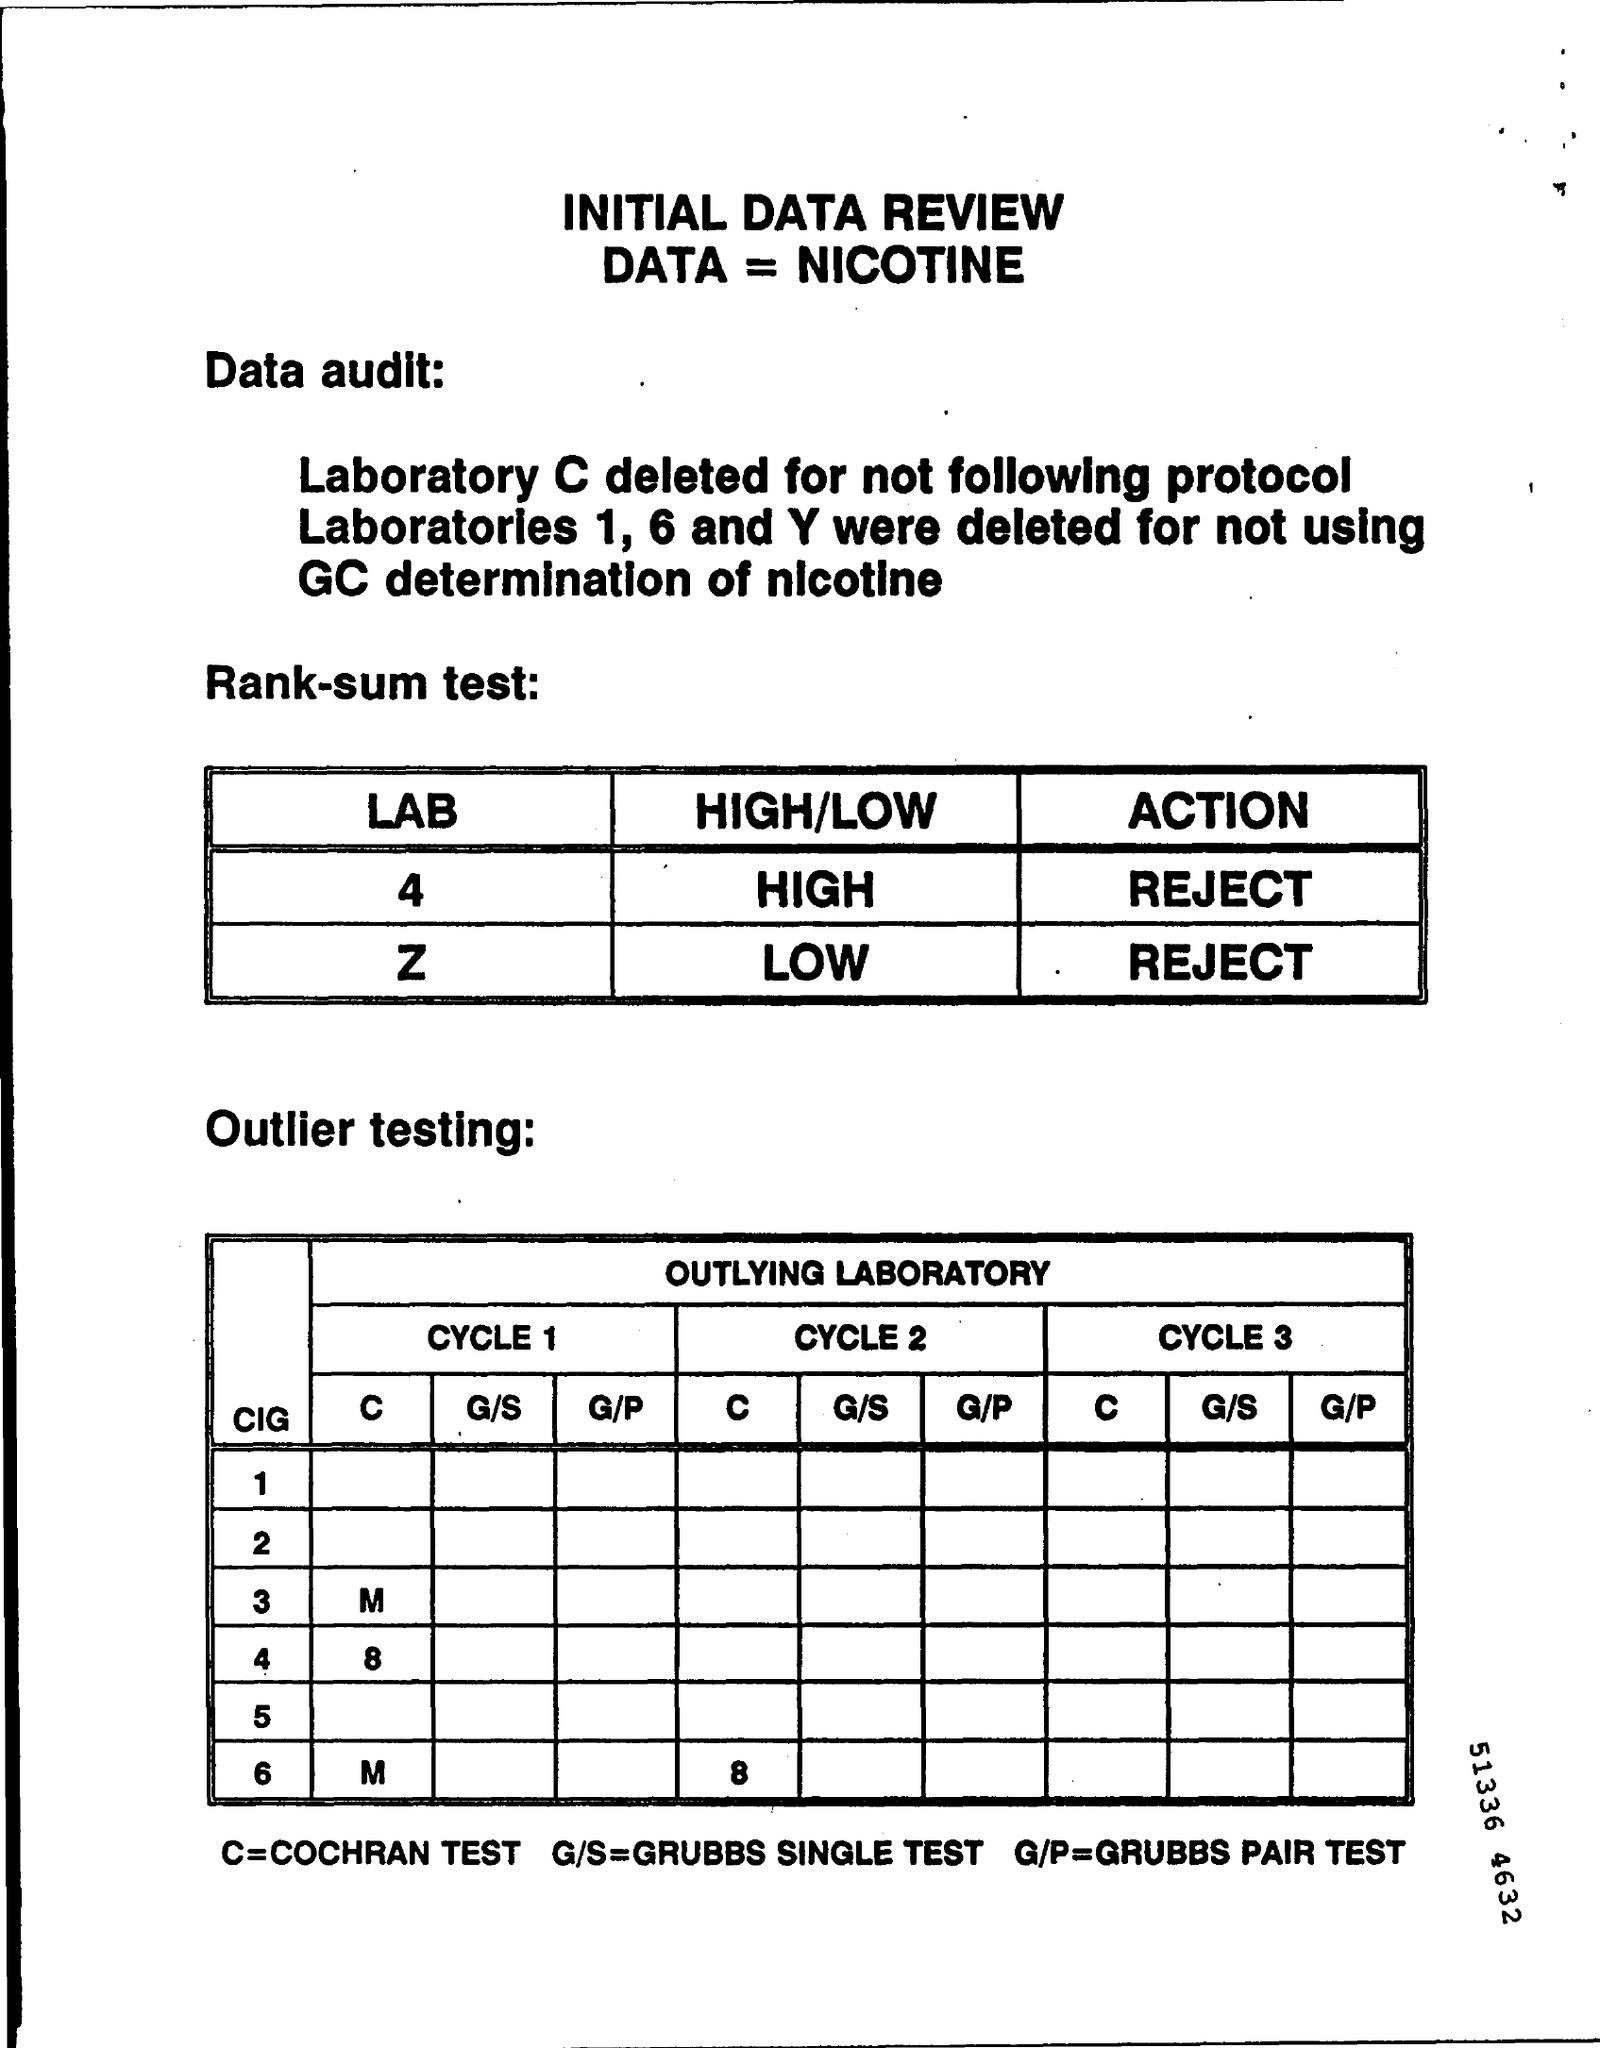What type of documentation is this?
Give a very brief answer. INITIAL DATA REVIEW. What does C stand for in the Outlier testing?
Your answer should be compact. Cochran Test. Why was Laboratory C deleted?
Offer a very short reply. For not following protocol. 